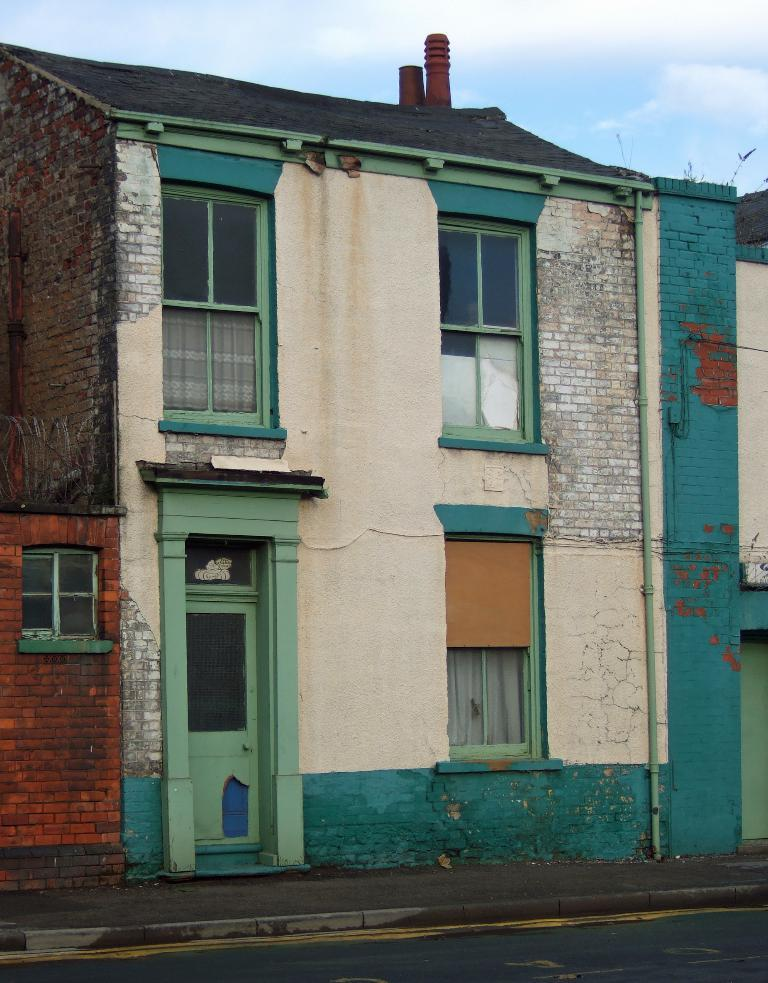What type of structure is visible in the image? There is a house in the image. What is located in front of the house? There is a road in front of the house. What can be seen in the background of the image? The sky is visible in the background of the image. How many babies are playing with matches in the image? There are no babies or matches present in the image. Are there any cows visible in the image? There are no cows present in the image. 